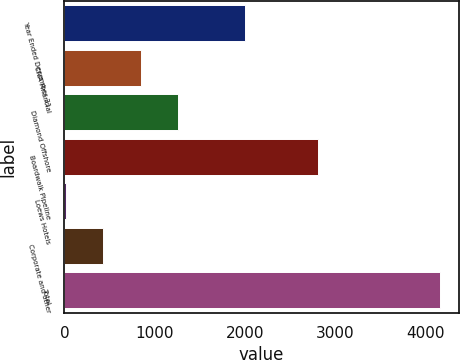<chart> <loc_0><loc_0><loc_500><loc_500><bar_chart><fcel>Year Ended December 31<fcel>CNA Financial<fcel>Diamond Offshore<fcel>Boardwalk Pipeline<fcel>Loews Hotels<fcel>Corporate and other<fcel>Total<nl><fcel>2008<fcel>844.6<fcel>1259.4<fcel>2812<fcel>15<fcel>429.8<fcel>4163<nl></chart> 